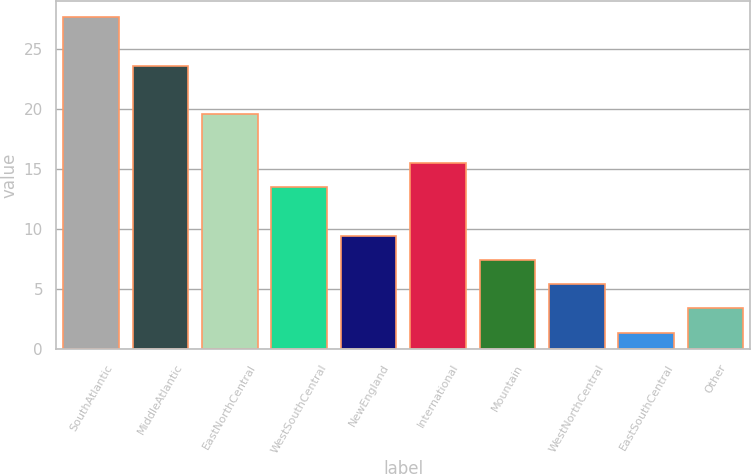Convert chart to OTSL. <chart><loc_0><loc_0><loc_500><loc_500><bar_chart><fcel>SouthAtlantic<fcel>MiddleAtlantic<fcel>EastNorthCentral<fcel>WestSouthCentral<fcel>NewEngland<fcel>International<fcel>Mountain<fcel>WestNorthCentral<fcel>EastSouthCentral<fcel>Other<nl><fcel>27.66<fcel>23.62<fcel>19.58<fcel>13.52<fcel>9.48<fcel>15.54<fcel>7.46<fcel>5.44<fcel>1.4<fcel>3.42<nl></chart> 